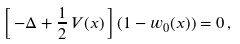<formula> <loc_0><loc_0><loc_500><loc_500>\left [ \, - \Delta + \frac { 1 } { 2 } \, { V ( x ) } \, \right ] ( 1 - w _ { 0 } ( x ) ) = 0 \, ,</formula> 